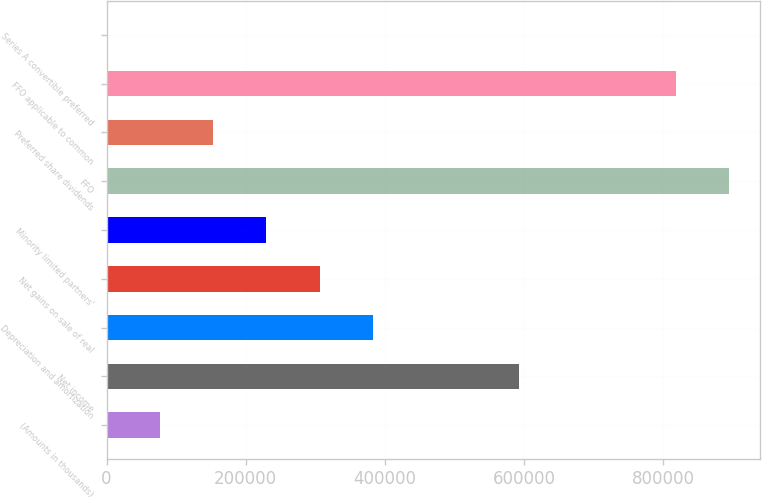<chart> <loc_0><loc_0><loc_500><loc_500><bar_chart><fcel>(Amounts in thousands)<fcel>Net income<fcel>Depreciation and amortization<fcel>Net gains on sale of real<fcel>Minority limited partners'<fcel>FFO<fcel>Preferred share dividends<fcel>FFO applicable to common<fcel>Series A convertible preferred<nl><fcel>77347.3<fcel>592917<fcel>382464<fcel>306185<fcel>229906<fcel>894500<fcel>153627<fcel>818220<fcel>1068<nl></chart> 